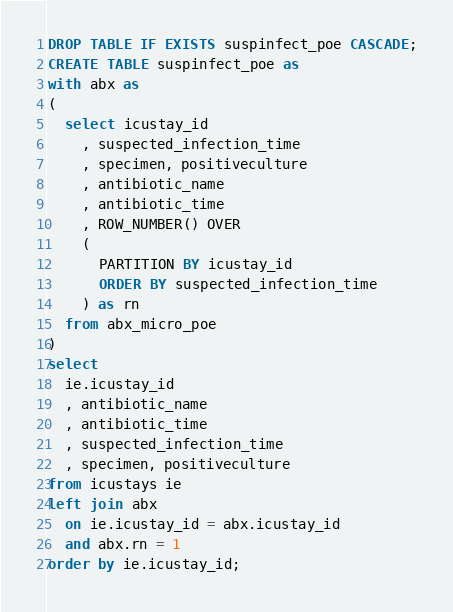<code> <loc_0><loc_0><loc_500><loc_500><_SQL_>DROP TABLE IF EXISTS suspinfect_poe CASCADE;
CREATE TABLE suspinfect_poe as
with abx as
(
  select icustay_id
    , suspected_infection_time
    , specimen, positiveculture
    , antibiotic_name
    , antibiotic_time
    , ROW_NUMBER() OVER
    (
      PARTITION BY icustay_id
      ORDER BY suspected_infection_time
    ) as rn
  from abx_micro_poe
)
select
  ie.icustay_id
  , antibiotic_name
  , antibiotic_time
  , suspected_infection_time
  , specimen, positiveculture
from icustays ie
left join abx
  on ie.icustay_id = abx.icustay_id
  and abx.rn = 1
order by ie.icustay_id;
</code> 